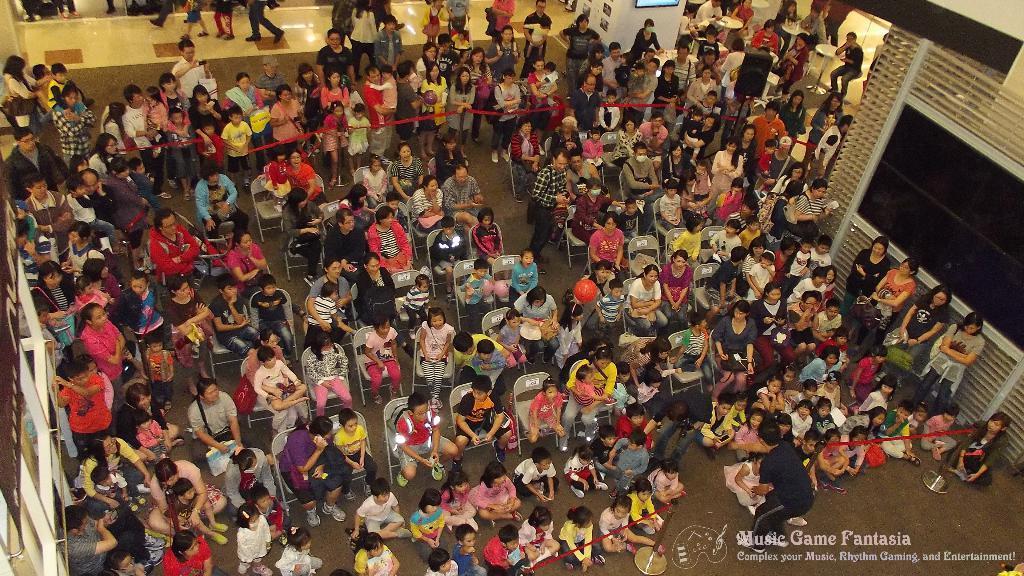How would you summarize this image in a sentence or two? In this picture, I can see a group of people, Who are sitting in chairs and they are few people, Who are standing and i can see a light black color mat towards left at top corner, We can see a tiles and few people walking. 